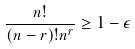Convert formula to latex. <formula><loc_0><loc_0><loc_500><loc_500>\frac { n ! } { ( n - r ) ! n ^ { r } } \geq 1 - \epsilon</formula> 